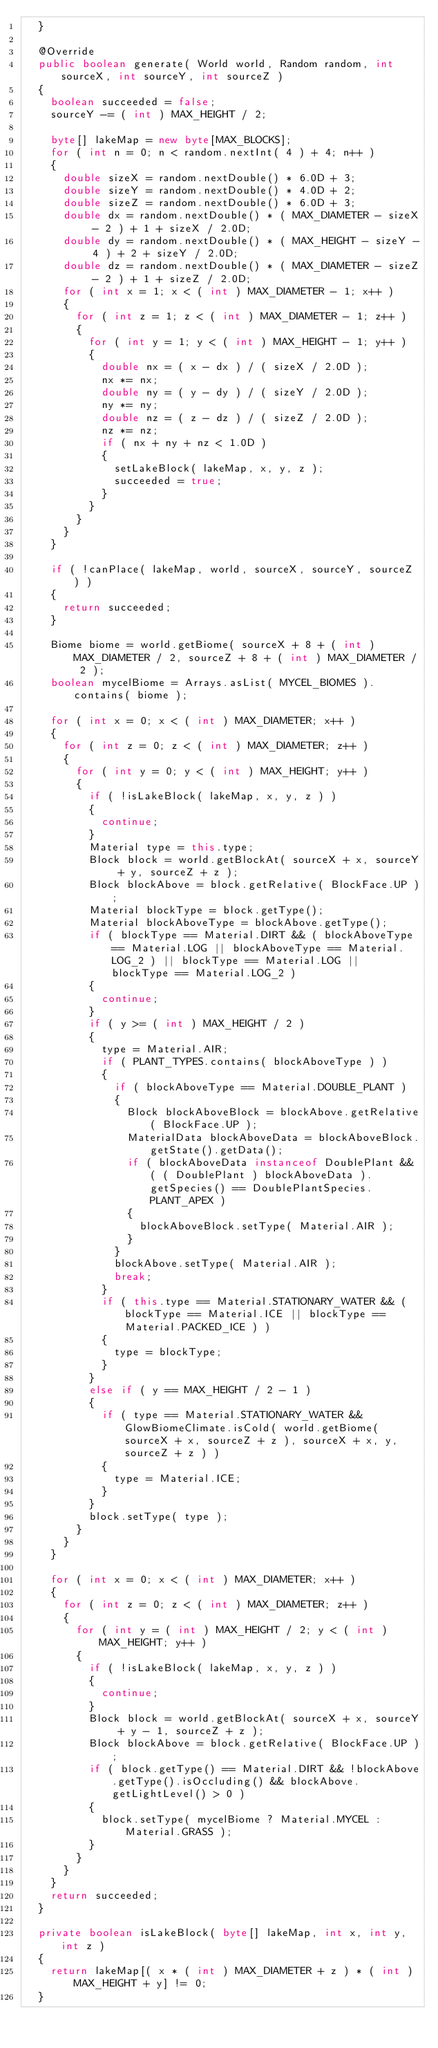<code> <loc_0><loc_0><loc_500><loc_500><_Java_>	}

	@Override
	public boolean generate( World world, Random random, int sourceX, int sourceY, int sourceZ )
	{
		boolean succeeded = false;
		sourceY -= ( int ) MAX_HEIGHT / 2;

		byte[] lakeMap = new byte[MAX_BLOCKS];
		for ( int n = 0; n < random.nextInt( 4 ) + 4; n++ )
		{
			double sizeX = random.nextDouble() * 6.0D + 3;
			double sizeY = random.nextDouble() * 4.0D + 2;
			double sizeZ = random.nextDouble() * 6.0D + 3;
			double dx = random.nextDouble() * ( MAX_DIAMETER - sizeX - 2 ) + 1 + sizeX / 2.0D;
			double dy = random.nextDouble() * ( MAX_HEIGHT - sizeY - 4 ) + 2 + sizeY / 2.0D;
			double dz = random.nextDouble() * ( MAX_DIAMETER - sizeZ - 2 ) + 1 + sizeZ / 2.0D;
			for ( int x = 1; x < ( int ) MAX_DIAMETER - 1; x++ )
			{
				for ( int z = 1; z < ( int ) MAX_DIAMETER - 1; z++ )
				{
					for ( int y = 1; y < ( int ) MAX_HEIGHT - 1; y++ )
					{
						double nx = ( x - dx ) / ( sizeX / 2.0D );
						nx *= nx;
						double ny = ( y - dy ) / ( sizeY / 2.0D );
						ny *= ny;
						double nz = ( z - dz ) / ( sizeZ / 2.0D );
						nz *= nz;
						if ( nx + ny + nz < 1.0D )
						{
							setLakeBlock( lakeMap, x, y, z );
							succeeded = true;
						}
					}
				}
			}
		}

		if ( !canPlace( lakeMap, world, sourceX, sourceY, sourceZ ) )
		{
			return succeeded;
		}

		Biome biome = world.getBiome( sourceX + 8 + ( int ) MAX_DIAMETER / 2, sourceZ + 8 + ( int ) MAX_DIAMETER / 2 );
		boolean mycelBiome = Arrays.asList( MYCEL_BIOMES ).contains( biome );

		for ( int x = 0; x < ( int ) MAX_DIAMETER; x++ )
		{
			for ( int z = 0; z < ( int ) MAX_DIAMETER; z++ )
			{
				for ( int y = 0; y < ( int ) MAX_HEIGHT; y++ )
				{
					if ( !isLakeBlock( lakeMap, x, y, z ) )
					{
						continue;
					}
					Material type = this.type;
					Block block = world.getBlockAt( sourceX + x, sourceY + y, sourceZ + z );
					Block blockAbove = block.getRelative( BlockFace.UP );
					Material blockType = block.getType();
					Material blockAboveType = blockAbove.getType();
					if ( blockType == Material.DIRT && ( blockAboveType == Material.LOG || blockAboveType == Material.LOG_2 ) || blockType == Material.LOG || blockType == Material.LOG_2 )
					{
						continue;
					}
					if ( y >= ( int ) MAX_HEIGHT / 2 )
					{
						type = Material.AIR;
						if ( PLANT_TYPES.contains( blockAboveType ) )
						{
							if ( blockAboveType == Material.DOUBLE_PLANT )
							{
								Block blockAboveBlock = blockAbove.getRelative( BlockFace.UP );
								MaterialData blockAboveData = blockAboveBlock.getState().getData();
								if ( blockAboveData instanceof DoublePlant && ( ( DoublePlant ) blockAboveData ).getSpecies() == DoublePlantSpecies.PLANT_APEX )
								{
									blockAboveBlock.setType( Material.AIR );
								}
							}
							blockAbove.setType( Material.AIR );
							break;
						}
						if ( this.type == Material.STATIONARY_WATER && ( blockType == Material.ICE || blockType == Material.PACKED_ICE ) )
						{
							type = blockType;
						}
					}
					else if ( y == MAX_HEIGHT / 2 - 1 )
					{
						if ( type == Material.STATIONARY_WATER && GlowBiomeClimate.isCold( world.getBiome( sourceX + x, sourceZ + z ), sourceX + x, y, sourceZ + z ) )
						{
							type = Material.ICE;
						}
					}
					block.setType( type );
				}
			}
		}

		for ( int x = 0; x < ( int ) MAX_DIAMETER; x++ )
		{
			for ( int z = 0; z < ( int ) MAX_DIAMETER; z++ )
			{
				for ( int y = ( int ) MAX_HEIGHT / 2; y < ( int ) MAX_HEIGHT; y++ )
				{
					if ( !isLakeBlock( lakeMap, x, y, z ) )
					{
						continue;
					}
					Block block = world.getBlockAt( sourceX + x, sourceY + y - 1, sourceZ + z );
					Block blockAbove = block.getRelative( BlockFace.UP );
					if ( block.getType() == Material.DIRT && !blockAbove.getType().isOccluding() && blockAbove.getLightLevel() > 0 )
					{
						block.setType( mycelBiome ? Material.MYCEL : Material.GRASS );
					}
				}
			}
		}
		return succeeded;
	}

	private boolean isLakeBlock( byte[] lakeMap, int x, int y, int z )
	{
		return lakeMap[( x * ( int ) MAX_DIAMETER + z ) * ( int ) MAX_HEIGHT + y] != 0;
	}
</code> 